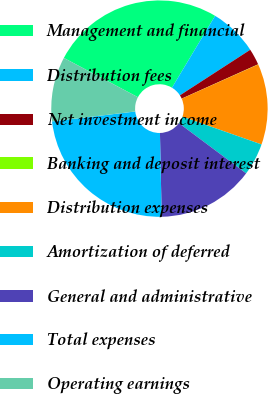Convert chart to OTSL. <chart><loc_0><loc_0><loc_500><loc_500><pie_chart><fcel>Management and financial<fcel>Distribution fees<fcel>Net investment income<fcel>Banking and deposit interest<fcel>Distribution expenses<fcel>Amortization of deferred<fcel>General and administrative<fcel>Total expenses<fcel>Operating earnings<nl><fcel>25.84%<fcel>7.25%<fcel>2.43%<fcel>0.03%<fcel>12.06%<fcel>4.84%<fcel>14.46%<fcel>23.44%<fcel>9.65%<nl></chart> 